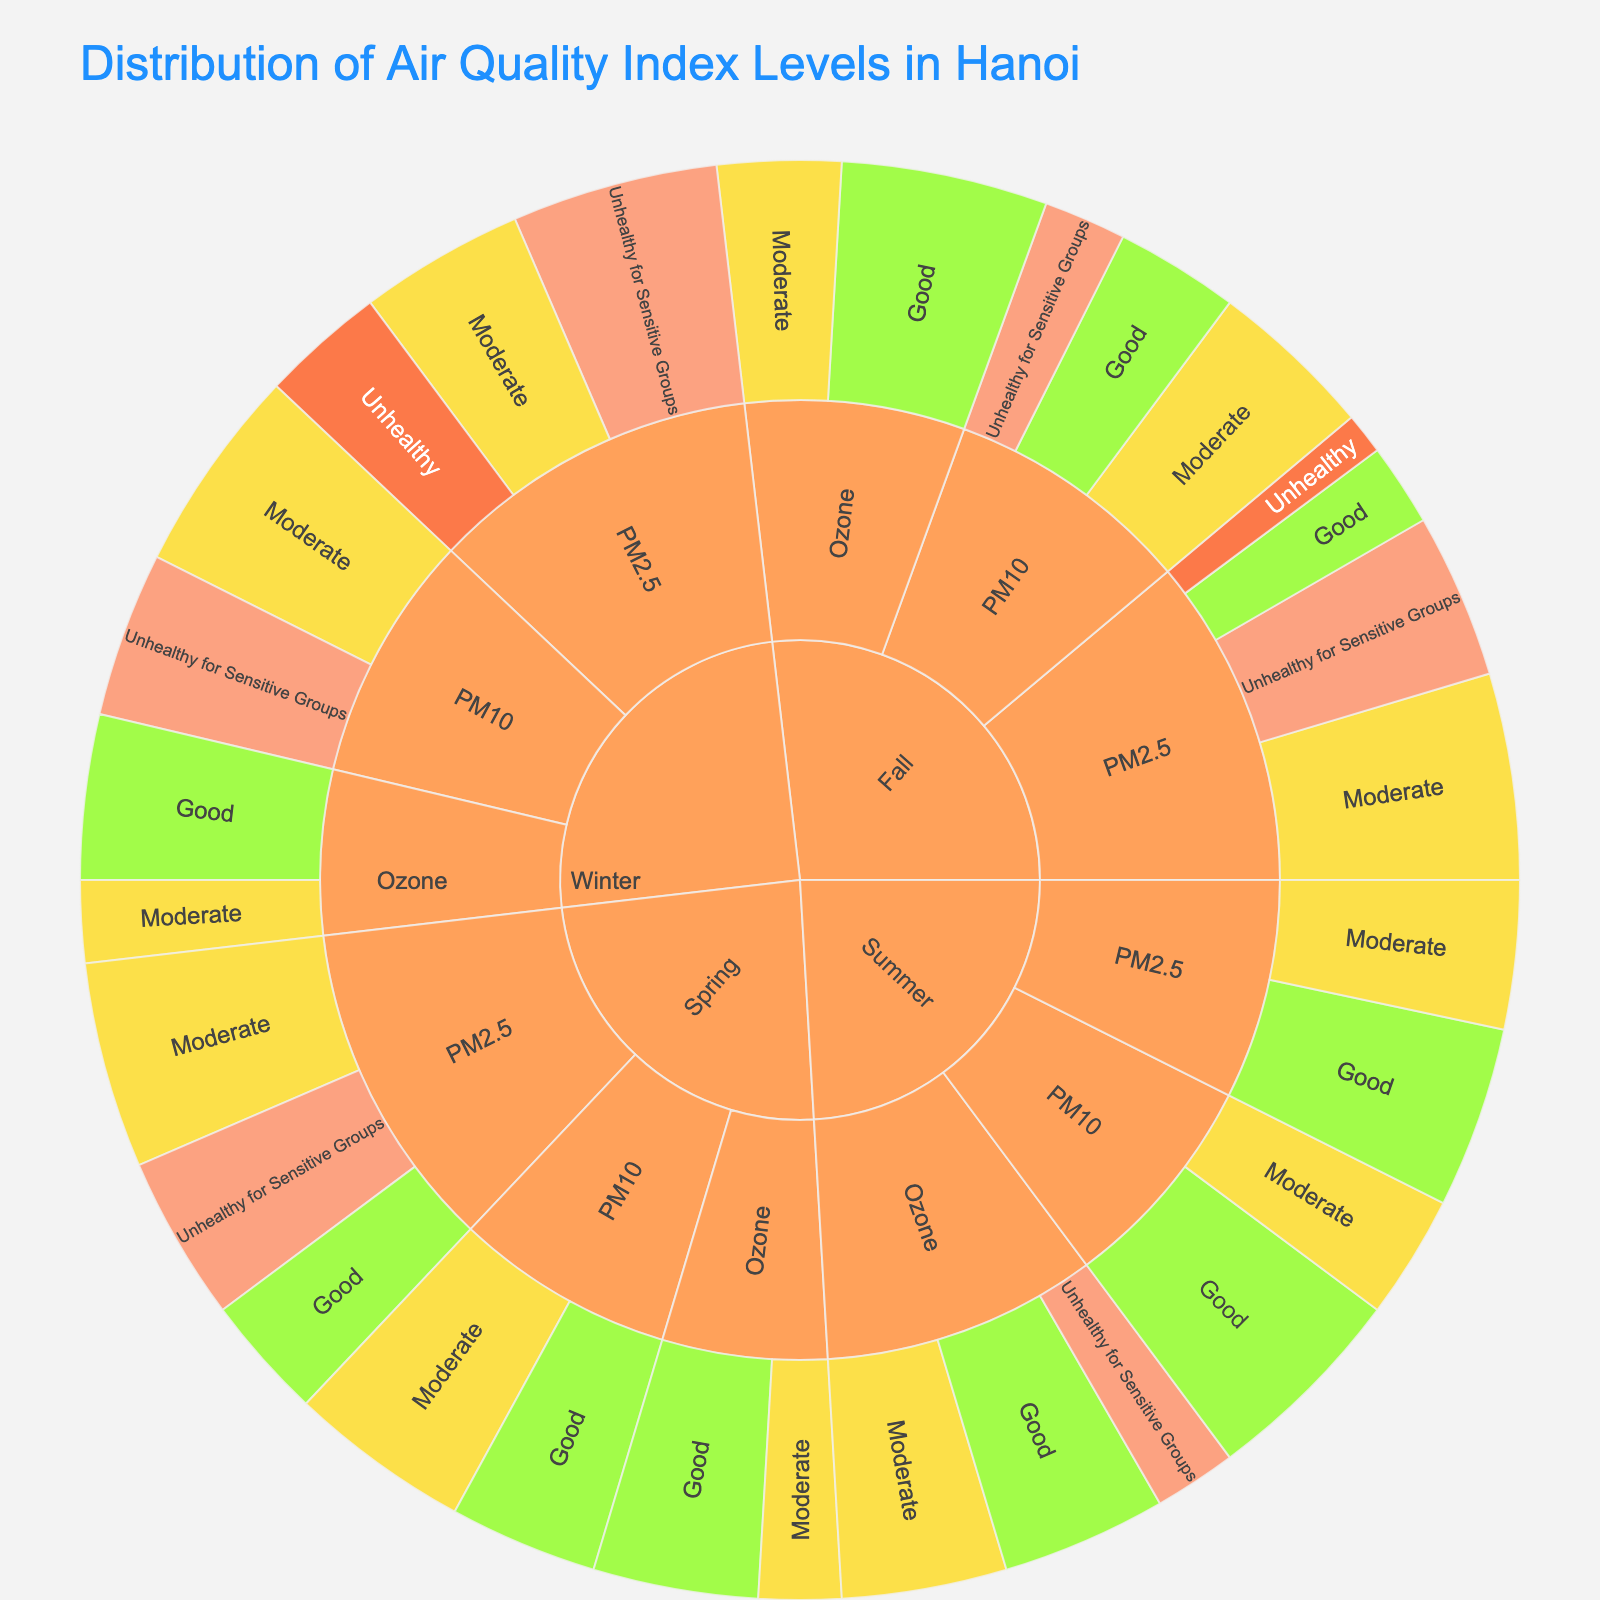What is the title of the Sunburst Plot? The title is usually placed at the top of the figure and indicates the overall topic of the visualization, which is easy to identify.
Answer: Distribution of Air Quality Index Levels in Hanoi What color represents 'Good' AQI levels in the plot? Sunburst plots use distinct colors to represent different categories, and the legend or color mapping shows which color corresponds to each category.
Answer: Light green In which season did 'PM2.5' have the highest value of 'Good' AQI levels? By examining the 'PM2.5' segments across each season, we can compare the values directly to find the highest one.
Answer: Summer How many total 'Moderate' AQI levels were recorded across all seasons for 'PM10'? Sum the values for 'Moderate' AQI levels under 'PM10' across Spring, Summer, Fall, and Winter to get the total. The sum is 22 (Spring) + 15 (Summer) + 20 (Fall) + 25 (Winter).
Answer: 82 Compare the number of 'Unhealthy for Sensitive Groups' AQI levels for 'Ozone' in Spring and Winter. Which season recorded more? Look at the 'Unhealthy for Sensitive Groups' segments under 'Ozone' for both Spring and Winter; then compare their values.
Answer: Spring recorded more What is the smallest value for 'Unhealthy' AQI levels for 'PM2.5' and in which season does it occur? Examine the 'Unhealthy' values for 'PM2.5' across all seasons. Identify which season has the smallest value by comparing the numbers.
Answer: Fall Which pollutant had 'Good' AQI levels in every season? Look for the presence of 'Good' AQI levels for each pollutant segment across all seasons to check consistency. 'Ozone' has 'Good' AQI levels in Spring, Summer, Fall, and Winter.
Answer: Ozone Calculate the average 'Moderate' AQI levels for 'PM2.5' across all seasons. Sum the values for 'Moderate' AQI levels under 'PM2.5' across all seasons and divide by the number of seasons (25 Spring + 18 Summer + 25 Fall + 20 Winter) / 4.
Answer: 22 